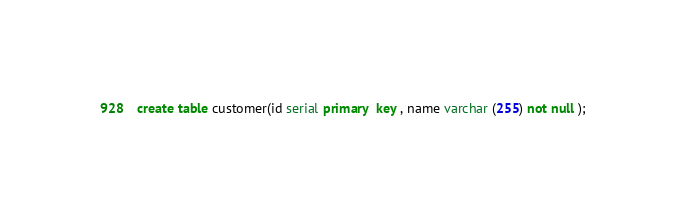Convert code to text. <code><loc_0><loc_0><loc_500><loc_500><_SQL_>create table customer(id serial primary  key , name varchar (255) not null );</code> 